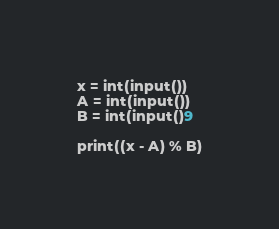<code> <loc_0><loc_0><loc_500><loc_500><_Python_>x = int(input())
A = int(input())
B = int(input()9

print((x - A) % B)
</code> 